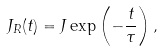<formula> <loc_0><loc_0><loc_500><loc_500>J _ { R } ( t ) = J \exp \left ( - \frac { t } { \tau } \right ) ,</formula> 